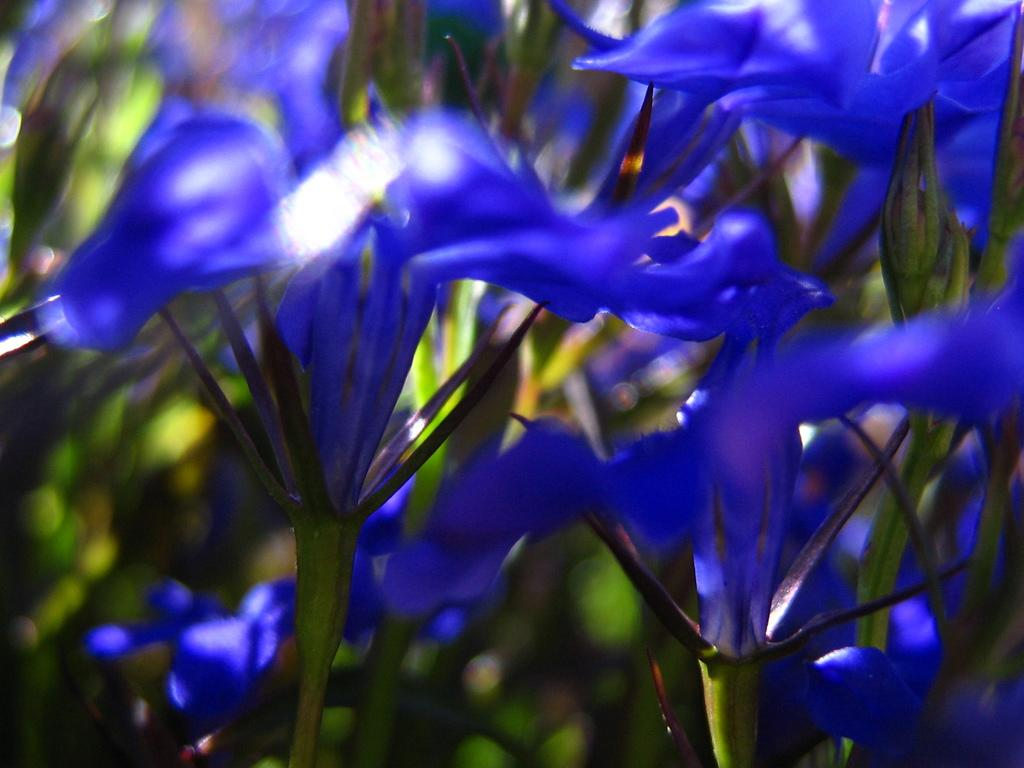Where was the image taken? The image is taken outdoors. What type of vegetation can be seen in the image? There are plants with green leaves in the image. What additional floral elements are present in the image? There are flowers in the image. What is the color of the flowers? The flowers are violet in color. Can you see any wings on the flowers in the image? No, there are no wings present on the flowers in the image. 